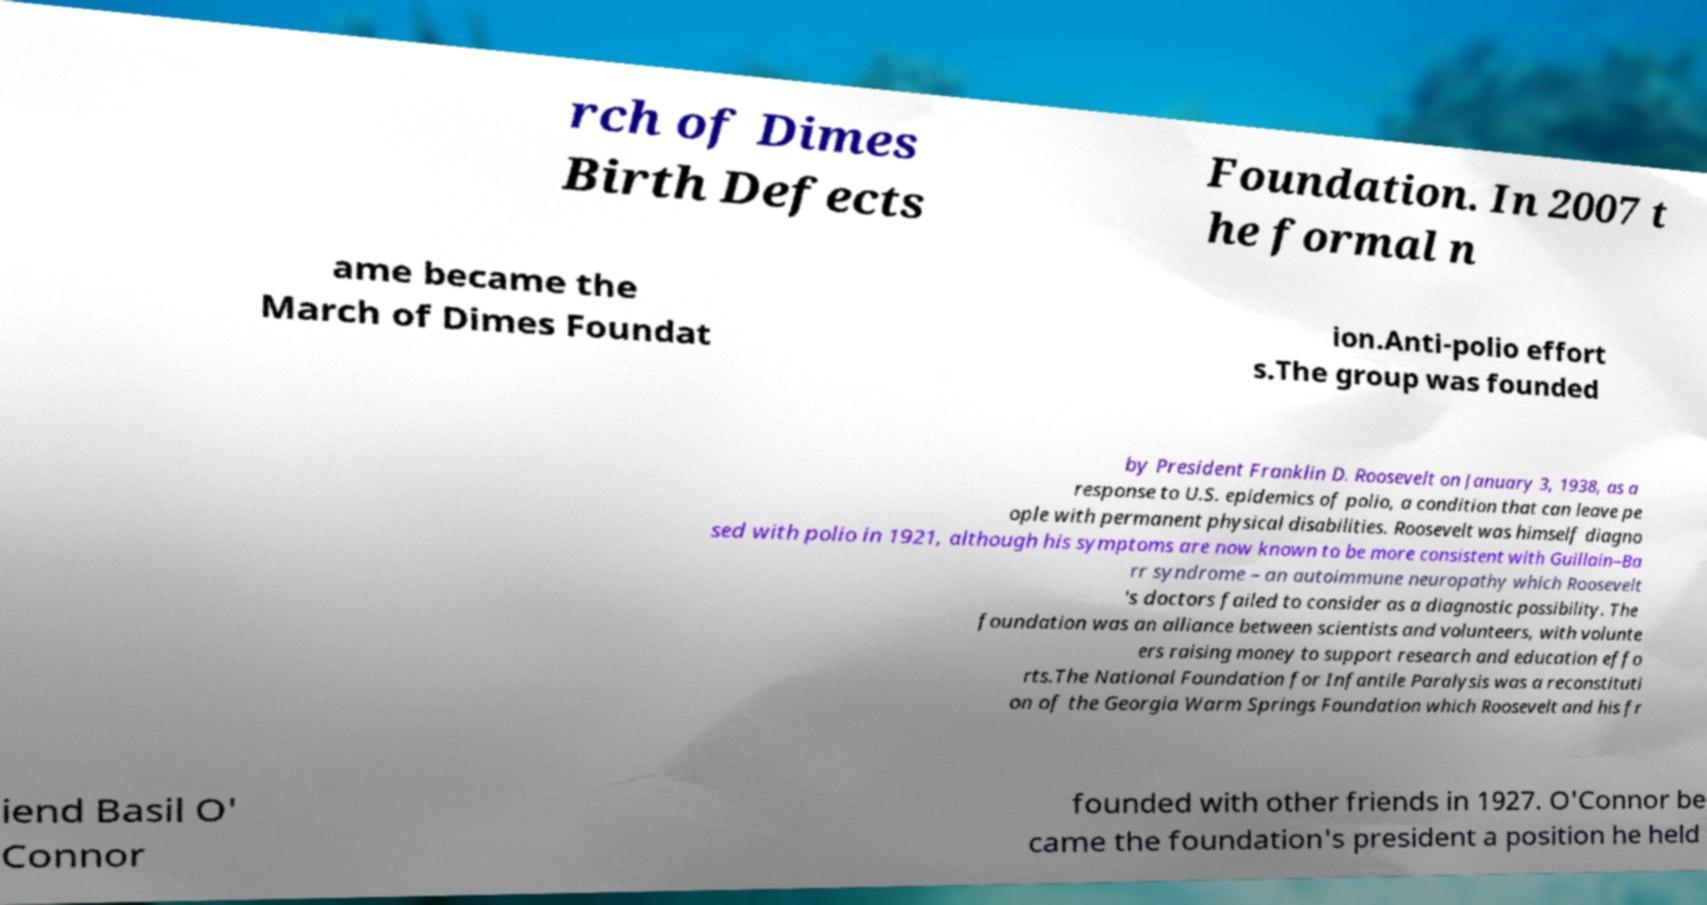I need the written content from this picture converted into text. Can you do that? rch of Dimes Birth Defects Foundation. In 2007 t he formal n ame became the March of Dimes Foundat ion.Anti-polio effort s.The group was founded by President Franklin D. Roosevelt on January 3, 1938, as a response to U.S. epidemics of polio, a condition that can leave pe ople with permanent physical disabilities. Roosevelt was himself diagno sed with polio in 1921, although his symptoms are now known to be more consistent with Guillain–Ba rr syndrome – an autoimmune neuropathy which Roosevelt 's doctors failed to consider as a diagnostic possibility. The foundation was an alliance between scientists and volunteers, with volunte ers raising money to support research and education effo rts.The National Foundation for Infantile Paralysis was a reconstituti on of the Georgia Warm Springs Foundation which Roosevelt and his fr iend Basil O' Connor founded with other friends in 1927. O'Connor be came the foundation's president a position he held 